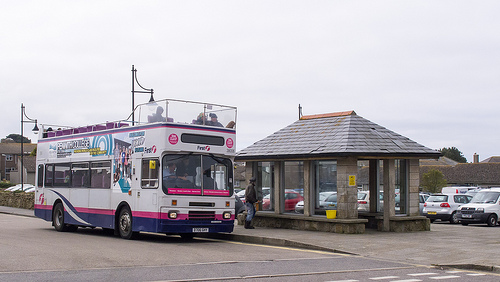Can you describe the setting of this image? This image depicts an overcast day at a bus stop. There's a double-decker bus parked near a shelter, where a person appears to be waiting or boarding. Several cars are visible in the background, indicating a parking area nearby. Is the bus stationary or moving? The bus appears stationary as it is parked next to a bus shelter. What could be the purpose of the people on the upper deck of the bus? The people on the upper deck of the bus might be sightseeing, given the unique perspective that a double-decker bus provides. They could also be enjoying an elevated view of their journey or simply commuting. Imagine if the bus could fly. How would the scene change? If the bus could fly, the scene would become quite fantastical. The bus would hover above the shelter and parking area, perhaps with wings or jets attached to its sides. People in the area might look up in amazement, and the bus might cast a large shadow over the surroundings as it floats gently through the air. This imagery would transform the everyday setting into a scene straight out of a whimsical story or a sci-fi movie. 